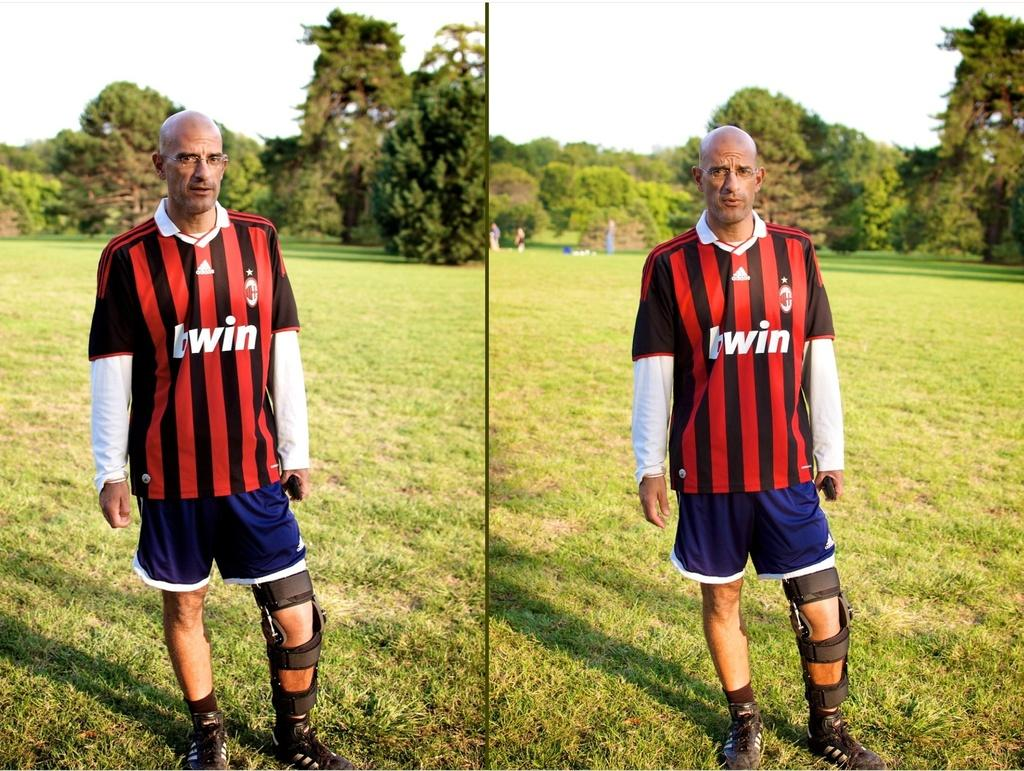<image>
Provide a brief description of the given image. Two images of the same chap wearing a black and red football top sponsored by Betwin as he stands in a field with a strapped up leg. 